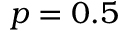<formula> <loc_0><loc_0><loc_500><loc_500>p = 0 . 5</formula> 